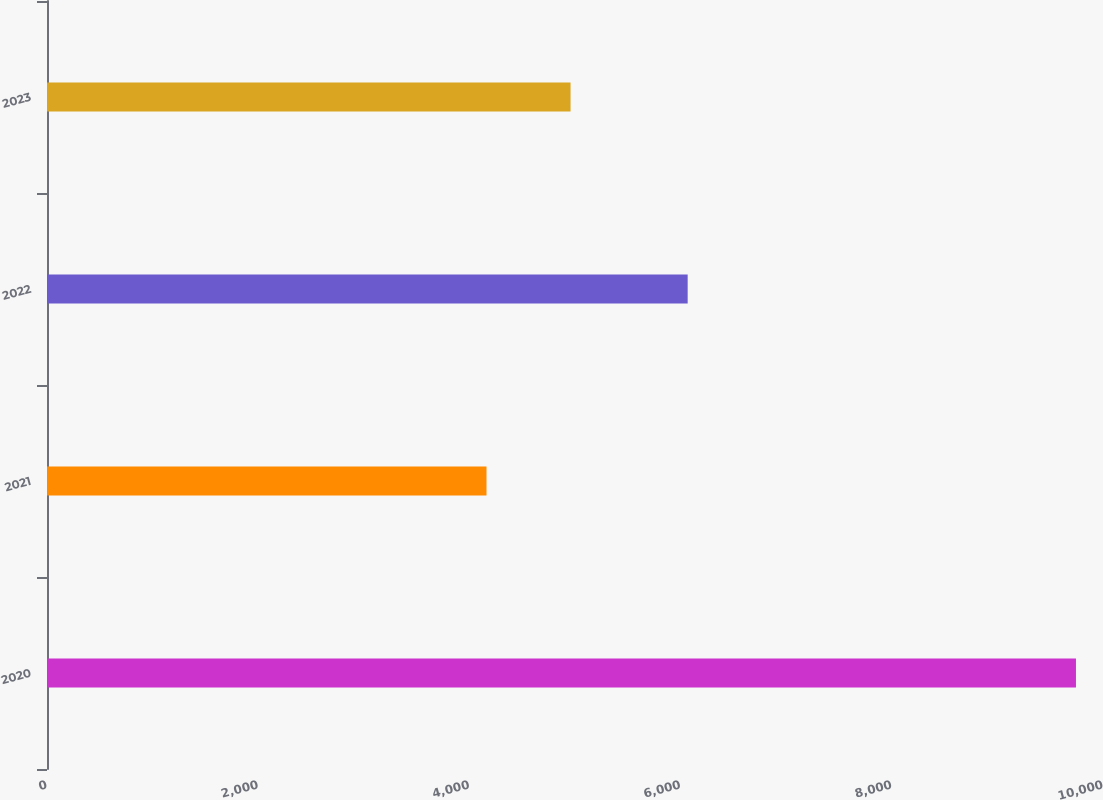Convert chart to OTSL. <chart><loc_0><loc_0><loc_500><loc_500><bar_chart><fcel>2020<fcel>2021<fcel>2022<fcel>2023<nl><fcel>9744<fcel>4162<fcel>6067<fcel>4958<nl></chart> 